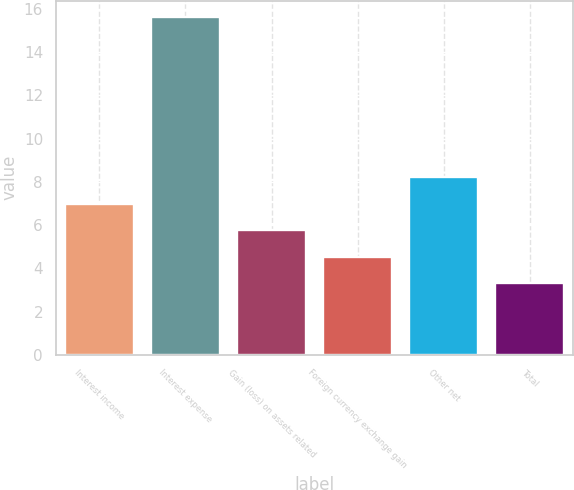<chart> <loc_0><loc_0><loc_500><loc_500><bar_chart><fcel>Interest income<fcel>Interest expense<fcel>Gain (loss) on assets related<fcel>Foreign currency exchange gain<fcel>Other net<fcel>Total<nl><fcel>6.99<fcel>15.6<fcel>5.76<fcel>4.53<fcel>8.22<fcel>3.3<nl></chart> 